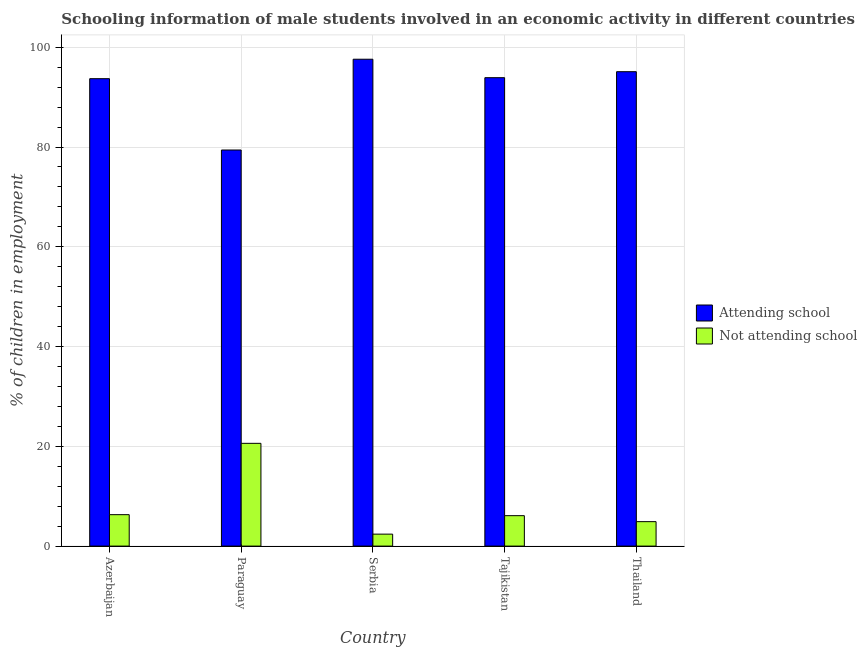How many different coloured bars are there?
Your answer should be compact. 2. How many groups of bars are there?
Offer a very short reply. 5. What is the label of the 4th group of bars from the left?
Provide a succinct answer. Tajikistan. Across all countries, what is the maximum percentage of employed males who are not attending school?
Provide a succinct answer. 20.6. Across all countries, what is the minimum percentage of employed males who are attending school?
Your answer should be very brief. 79.4. In which country was the percentage of employed males who are attending school maximum?
Offer a terse response. Serbia. In which country was the percentage of employed males who are attending school minimum?
Give a very brief answer. Paraguay. What is the total percentage of employed males who are not attending school in the graph?
Make the answer very short. 40.3. What is the difference between the percentage of employed males who are attending school in Tajikistan and that in Thailand?
Your answer should be compact. -1.2. What is the difference between the percentage of employed males who are not attending school in Thailand and the percentage of employed males who are attending school in Serbia?
Offer a very short reply. -92.7. What is the average percentage of employed males who are attending school per country?
Offer a terse response. 91.94. What is the difference between the percentage of employed males who are not attending school and percentage of employed males who are attending school in Serbia?
Give a very brief answer. -95.2. What is the ratio of the percentage of employed males who are not attending school in Tajikistan to that in Thailand?
Keep it short and to the point. 1.24. Is the percentage of employed males who are not attending school in Azerbaijan less than that in Tajikistan?
Your response must be concise. No. Is the difference between the percentage of employed males who are not attending school in Serbia and Thailand greater than the difference between the percentage of employed males who are attending school in Serbia and Thailand?
Keep it short and to the point. No. What is the difference between the highest and the second highest percentage of employed males who are not attending school?
Your answer should be very brief. 14.3. What is the difference between the highest and the lowest percentage of employed males who are attending school?
Provide a succinct answer. 18.2. What does the 1st bar from the left in Tajikistan represents?
Your answer should be compact. Attending school. What does the 1st bar from the right in Azerbaijan represents?
Make the answer very short. Not attending school. How many bars are there?
Offer a very short reply. 10. Are the values on the major ticks of Y-axis written in scientific E-notation?
Keep it short and to the point. No. Where does the legend appear in the graph?
Give a very brief answer. Center right. What is the title of the graph?
Provide a succinct answer. Schooling information of male students involved in an economic activity in different countries. What is the label or title of the X-axis?
Keep it short and to the point. Country. What is the label or title of the Y-axis?
Your answer should be compact. % of children in employment. What is the % of children in employment in Attending school in Azerbaijan?
Offer a terse response. 93.7. What is the % of children in employment in Not attending school in Azerbaijan?
Provide a short and direct response. 6.3. What is the % of children in employment of Attending school in Paraguay?
Ensure brevity in your answer.  79.4. What is the % of children in employment of Not attending school in Paraguay?
Provide a short and direct response. 20.6. What is the % of children in employment in Attending school in Serbia?
Provide a succinct answer. 97.6. What is the % of children in employment of Not attending school in Serbia?
Your answer should be very brief. 2.4. What is the % of children in employment in Attending school in Tajikistan?
Your response must be concise. 93.9. What is the % of children in employment in Attending school in Thailand?
Make the answer very short. 95.1. What is the % of children in employment in Not attending school in Thailand?
Your answer should be very brief. 4.9. Across all countries, what is the maximum % of children in employment in Attending school?
Give a very brief answer. 97.6. Across all countries, what is the maximum % of children in employment of Not attending school?
Your response must be concise. 20.6. Across all countries, what is the minimum % of children in employment of Attending school?
Make the answer very short. 79.4. What is the total % of children in employment in Attending school in the graph?
Offer a very short reply. 459.7. What is the total % of children in employment of Not attending school in the graph?
Your response must be concise. 40.3. What is the difference between the % of children in employment in Not attending school in Azerbaijan and that in Paraguay?
Your answer should be compact. -14.3. What is the difference between the % of children in employment in Attending school in Azerbaijan and that in Serbia?
Make the answer very short. -3.9. What is the difference between the % of children in employment of Not attending school in Azerbaijan and that in Tajikistan?
Your answer should be compact. 0.2. What is the difference between the % of children in employment in Attending school in Azerbaijan and that in Thailand?
Your answer should be compact. -1.4. What is the difference between the % of children in employment in Not attending school in Azerbaijan and that in Thailand?
Offer a very short reply. 1.4. What is the difference between the % of children in employment of Attending school in Paraguay and that in Serbia?
Give a very brief answer. -18.2. What is the difference between the % of children in employment of Not attending school in Paraguay and that in Serbia?
Your answer should be very brief. 18.2. What is the difference between the % of children in employment of Attending school in Paraguay and that in Thailand?
Ensure brevity in your answer.  -15.7. What is the difference between the % of children in employment in Not attending school in Paraguay and that in Thailand?
Your answer should be compact. 15.7. What is the difference between the % of children in employment in Not attending school in Tajikistan and that in Thailand?
Offer a terse response. 1.2. What is the difference between the % of children in employment of Attending school in Azerbaijan and the % of children in employment of Not attending school in Paraguay?
Give a very brief answer. 73.1. What is the difference between the % of children in employment in Attending school in Azerbaijan and the % of children in employment in Not attending school in Serbia?
Your response must be concise. 91.3. What is the difference between the % of children in employment in Attending school in Azerbaijan and the % of children in employment in Not attending school in Tajikistan?
Provide a succinct answer. 87.6. What is the difference between the % of children in employment in Attending school in Azerbaijan and the % of children in employment in Not attending school in Thailand?
Your answer should be very brief. 88.8. What is the difference between the % of children in employment of Attending school in Paraguay and the % of children in employment of Not attending school in Tajikistan?
Ensure brevity in your answer.  73.3. What is the difference between the % of children in employment of Attending school in Paraguay and the % of children in employment of Not attending school in Thailand?
Your answer should be compact. 74.5. What is the difference between the % of children in employment in Attending school in Serbia and the % of children in employment in Not attending school in Tajikistan?
Give a very brief answer. 91.5. What is the difference between the % of children in employment in Attending school in Serbia and the % of children in employment in Not attending school in Thailand?
Give a very brief answer. 92.7. What is the difference between the % of children in employment in Attending school in Tajikistan and the % of children in employment in Not attending school in Thailand?
Your answer should be very brief. 89. What is the average % of children in employment in Attending school per country?
Ensure brevity in your answer.  91.94. What is the average % of children in employment of Not attending school per country?
Keep it short and to the point. 8.06. What is the difference between the % of children in employment of Attending school and % of children in employment of Not attending school in Azerbaijan?
Give a very brief answer. 87.4. What is the difference between the % of children in employment in Attending school and % of children in employment in Not attending school in Paraguay?
Your response must be concise. 58.8. What is the difference between the % of children in employment in Attending school and % of children in employment in Not attending school in Serbia?
Your answer should be compact. 95.2. What is the difference between the % of children in employment in Attending school and % of children in employment in Not attending school in Tajikistan?
Offer a very short reply. 87.8. What is the difference between the % of children in employment in Attending school and % of children in employment in Not attending school in Thailand?
Ensure brevity in your answer.  90.2. What is the ratio of the % of children in employment in Attending school in Azerbaijan to that in Paraguay?
Your response must be concise. 1.18. What is the ratio of the % of children in employment of Not attending school in Azerbaijan to that in Paraguay?
Your answer should be compact. 0.31. What is the ratio of the % of children in employment in Not attending school in Azerbaijan to that in Serbia?
Provide a succinct answer. 2.62. What is the ratio of the % of children in employment in Not attending school in Azerbaijan to that in Tajikistan?
Ensure brevity in your answer.  1.03. What is the ratio of the % of children in employment of Attending school in Paraguay to that in Serbia?
Provide a short and direct response. 0.81. What is the ratio of the % of children in employment of Not attending school in Paraguay to that in Serbia?
Provide a succinct answer. 8.58. What is the ratio of the % of children in employment in Attending school in Paraguay to that in Tajikistan?
Your answer should be very brief. 0.85. What is the ratio of the % of children in employment of Not attending school in Paraguay to that in Tajikistan?
Provide a succinct answer. 3.38. What is the ratio of the % of children in employment of Attending school in Paraguay to that in Thailand?
Give a very brief answer. 0.83. What is the ratio of the % of children in employment in Not attending school in Paraguay to that in Thailand?
Offer a very short reply. 4.2. What is the ratio of the % of children in employment in Attending school in Serbia to that in Tajikistan?
Keep it short and to the point. 1.04. What is the ratio of the % of children in employment in Not attending school in Serbia to that in Tajikistan?
Offer a very short reply. 0.39. What is the ratio of the % of children in employment in Attending school in Serbia to that in Thailand?
Offer a terse response. 1.03. What is the ratio of the % of children in employment of Not attending school in Serbia to that in Thailand?
Offer a very short reply. 0.49. What is the ratio of the % of children in employment of Attending school in Tajikistan to that in Thailand?
Your response must be concise. 0.99. What is the ratio of the % of children in employment in Not attending school in Tajikistan to that in Thailand?
Your answer should be compact. 1.24. What is the difference between the highest and the second highest % of children in employment of Not attending school?
Your response must be concise. 14.3. What is the difference between the highest and the lowest % of children in employment of Attending school?
Give a very brief answer. 18.2. What is the difference between the highest and the lowest % of children in employment of Not attending school?
Keep it short and to the point. 18.2. 